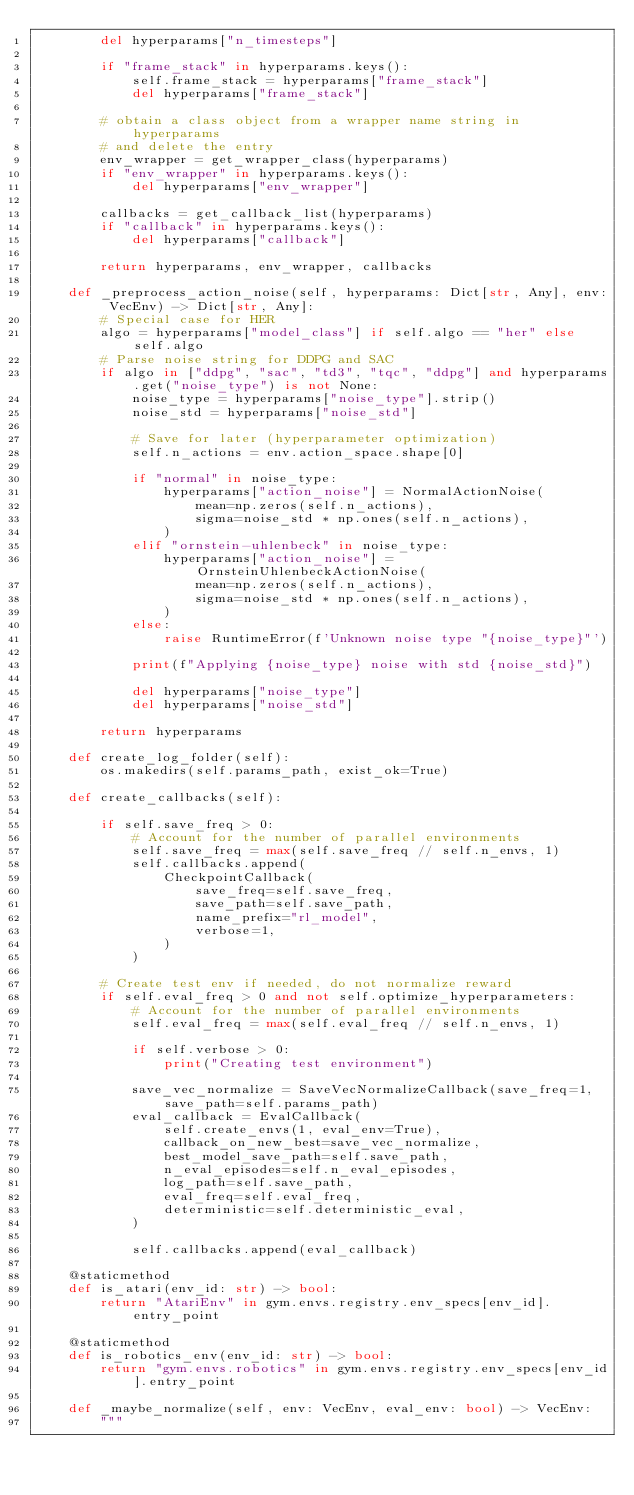<code> <loc_0><loc_0><loc_500><loc_500><_Python_>        del hyperparams["n_timesteps"]

        if "frame_stack" in hyperparams.keys():
            self.frame_stack = hyperparams["frame_stack"]
            del hyperparams["frame_stack"]

        # obtain a class object from a wrapper name string in hyperparams
        # and delete the entry
        env_wrapper = get_wrapper_class(hyperparams)
        if "env_wrapper" in hyperparams.keys():
            del hyperparams["env_wrapper"]

        callbacks = get_callback_list(hyperparams)
        if "callback" in hyperparams.keys():
            del hyperparams["callback"]

        return hyperparams, env_wrapper, callbacks

    def _preprocess_action_noise(self, hyperparams: Dict[str, Any], env: VecEnv) -> Dict[str, Any]:
        # Special case for HER
        algo = hyperparams["model_class"] if self.algo == "her" else self.algo
        # Parse noise string for DDPG and SAC
        if algo in ["ddpg", "sac", "td3", "tqc", "ddpg"] and hyperparams.get("noise_type") is not None:
            noise_type = hyperparams["noise_type"].strip()
            noise_std = hyperparams["noise_std"]

            # Save for later (hyperparameter optimization)
            self.n_actions = env.action_space.shape[0]

            if "normal" in noise_type:
                hyperparams["action_noise"] = NormalActionNoise(
                    mean=np.zeros(self.n_actions),
                    sigma=noise_std * np.ones(self.n_actions),
                )
            elif "ornstein-uhlenbeck" in noise_type:
                hyperparams["action_noise"] = OrnsteinUhlenbeckActionNoise(
                    mean=np.zeros(self.n_actions),
                    sigma=noise_std * np.ones(self.n_actions),
                )
            else:
                raise RuntimeError(f'Unknown noise type "{noise_type}"')

            print(f"Applying {noise_type} noise with std {noise_std}")

            del hyperparams["noise_type"]
            del hyperparams["noise_std"]

        return hyperparams

    def create_log_folder(self):
        os.makedirs(self.params_path, exist_ok=True)

    def create_callbacks(self):

        if self.save_freq > 0:
            # Account for the number of parallel environments
            self.save_freq = max(self.save_freq // self.n_envs, 1)
            self.callbacks.append(
                CheckpointCallback(
                    save_freq=self.save_freq,
                    save_path=self.save_path,
                    name_prefix="rl_model",
                    verbose=1,
                )
            )

        # Create test env if needed, do not normalize reward
        if self.eval_freq > 0 and not self.optimize_hyperparameters:
            # Account for the number of parallel environments
            self.eval_freq = max(self.eval_freq // self.n_envs, 1)

            if self.verbose > 0:
                print("Creating test environment")

            save_vec_normalize = SaveVecNormalizeCallback(save_freq=1, save_path=self.params_path)
            eval_callback = EvalCallback(
                self.create_envs(1, eval_env=True),
                callback_on_new_best=save_vec_normalize,
                best_model_save_path=self.save_path,
                n_eval_episodes=self.n_eval_episodes,
                log_path=self.save_path,
                eval_freq=self.eval_freq,
                deterministic=self.deterministic_eval,
            )

            self.callbacks.append(eval_callback)

    @staticmethod
    def is_atari(env_id: str) -> bool:
        return "AtariEnv" in gym.envs.registry.env_specs[env_id].entry_point

    @staticmethod
    def is_robotics_env(env_id: str) -> bool:
        return "gym.envs.robotics" in gym.envs.registry.env_specs[env_id].entry_point

    def _maybe_normalize(self, env: VecEnv, eval_env: bool) -> VecEnv:
        """</code> 